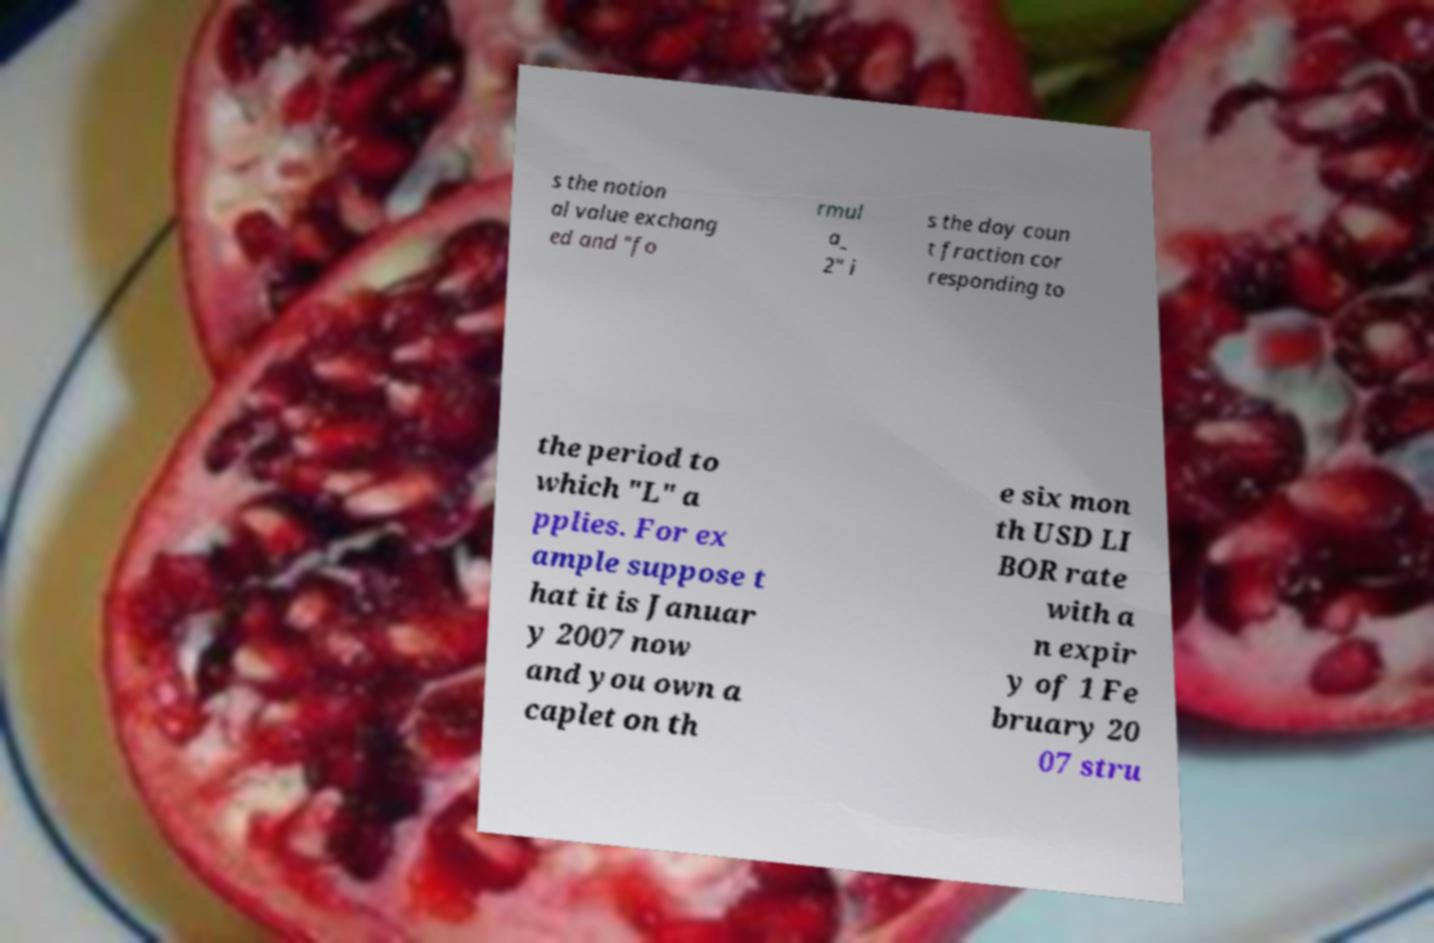For documentation purposes, I need the text within this image transcribed. Could you provide that? s the notion al value exchang ed and "fo rmul a_ 2" i s the day coun t fraction cor responding to the period to which "L" a pplies. For ex ample suppose t hat it is Januar y 2007 now and you own a caplet on th e six mon th USD LI BOR rate with a n expir y of 1 Fe bruary 20 07 stru 